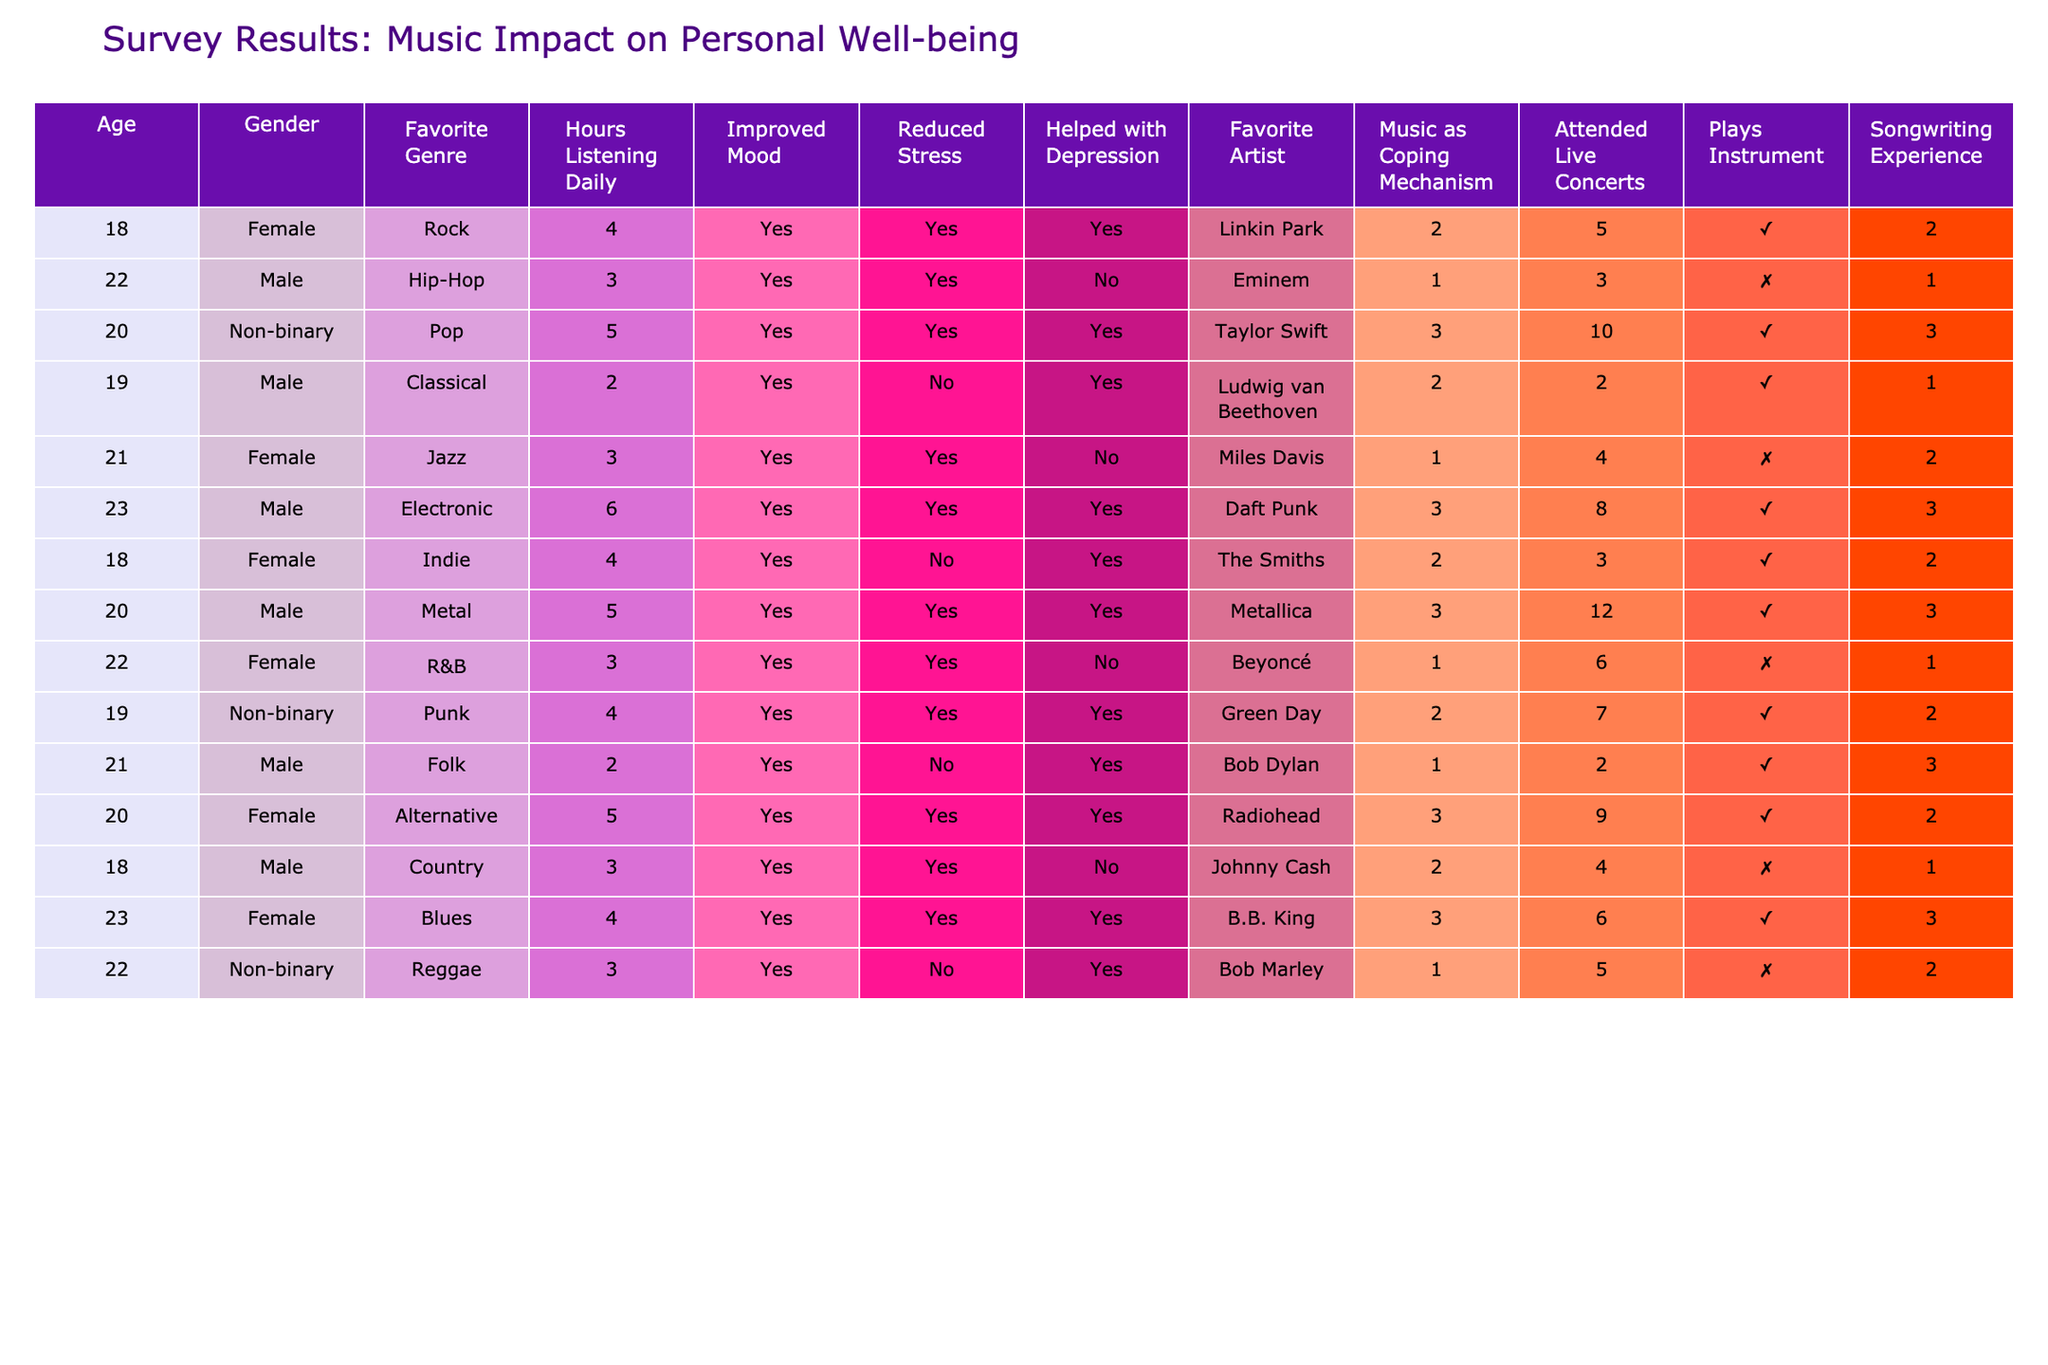What is the most listened to genre among respondents? By looking at the "Favorite Genre" column, I can find the genre that is listed most frequently. The genres listed are Rock, Hip-Hop, Pop, Classical, Jazz, Electronic, Indie, Metal, R&B, Punk, Folk, Alternative, Country, Blues, and Reggae. Counting the occurrences, Rock, Pop, and Electronic appear the most among the respondents.
Answer: Rock, Pop, and Electronic How many respondents reported that music helped with depression? To find this, I will check the "Helped with Depression" column and count the number of respondents who answered "Yes". The entries with "Yes" are from Linkin Park, Taylor Swift, Ludwing van Beethoven, The Smiths, Green Day, Bob Dylan, Radiohead, and B.B. King, which gives a total of 7.
Answer: 7 What percentage of respondents listen to music for over 4 hours daily? I will count the number of respondents whose "Hours Listening Daily" is greater than 4 and then divide this by the total number of respondents (which is 15). The respondents who listen more than 4 hours daily are those who reported 5 or 6 hours (Taylor Swift, Metallica, The Smiths, Daft Punk, and Radiohead), resulting in 6 individuals. Thus, the percentage is (6/15) * 100 = 40%.
Answer: 40% Do all respondents who play an instrument also have songwriting experience? I will cross-reference the "Plays Instrument" and "Songwriting Experience" columns. Among the 7 respondents who play an instrument, there are extensive or some songwriting experiences, while 2 reported none. Therefore, not all respondents who play an instrument have songwriting experience.
Answer: No Which artist is most frequently associated with a coping mechanism of "Always"? I will look at the "Music as Coping Mechanism" column and identify the entries with "Always". Then, I'll check the associated artists for those records. The artists with the "Always" response are Taylor Swift, Daft Punk, Metallica, Green Day, and B.B. King. Since there are multiple entries with "Always", I will count each artist and find that Taylor Swift, Daft Punk, Metallica, and B.B. King appear as "Always", each associated with 1 entry. Thus, multiple artists are associated equally in this category.
Answer: Multiple artists (Taylor Swift, Daft Punk, Metallica, B.B. King) What is the average age of respondents who prefer Rock music? I first filter the "Age" of respondents who have "Favorite Genre" as Rock. There are 2 respondents who listed Rock (one at age 18). To find the average, I sum their ages (18) and divide by the number of respondents (1) to get 18.
Answer: 18 How many respondents who reported improved mood also listen to Jazz? I will count the number of respondents in the "Improved Mood" column marked "Yes" who have "Favorite Genre" set to Jazz. The only individual who listens to Jazz (Miles Davis) reported improved mood, thus the count is 1.
Answer: 1 Is there a correlation between attending live concerts and music as a coping mechanism? To check this, I will examine the "Attended Live Concerts" and "Music as Coping Mechanism" columns together. I will determine the number of respondents who attended concerts and categorize their coping mechanisms. Out of 15 respondents, 9 attended concerts, and among them, 7 report using music "Often" or "Always" as a coping mechanism. Therefore, attending concerts seems to correlate positively with the use of music as a coping mechanism.
Answer: Yes What is the total number of hours respondents listened to music daily? I add up all the "Hours Listening Daily" values from the table. The total is 4 + 3 + 5 + 2 + 3 + 6 + 4 + 5 + 3 + 4 + 2 + 5 + 3 + 4 + 3 = 61.
Answer: 61 How does the presence of a favorite artist influence the reported reduction in stress? To examine this, I will cross-reference the favorite artists with the "Reduced Stress" responses. I'll analyze how many respondents reported "Yes" or "No" for reduced stress alongside their favorite artists. Among the 15 respondents, 10 reported reduction in stress and they have various favorite artists suggesting that many artists seem to help with stress reduction.
Answer: Yes, many artists help with stress reduction 